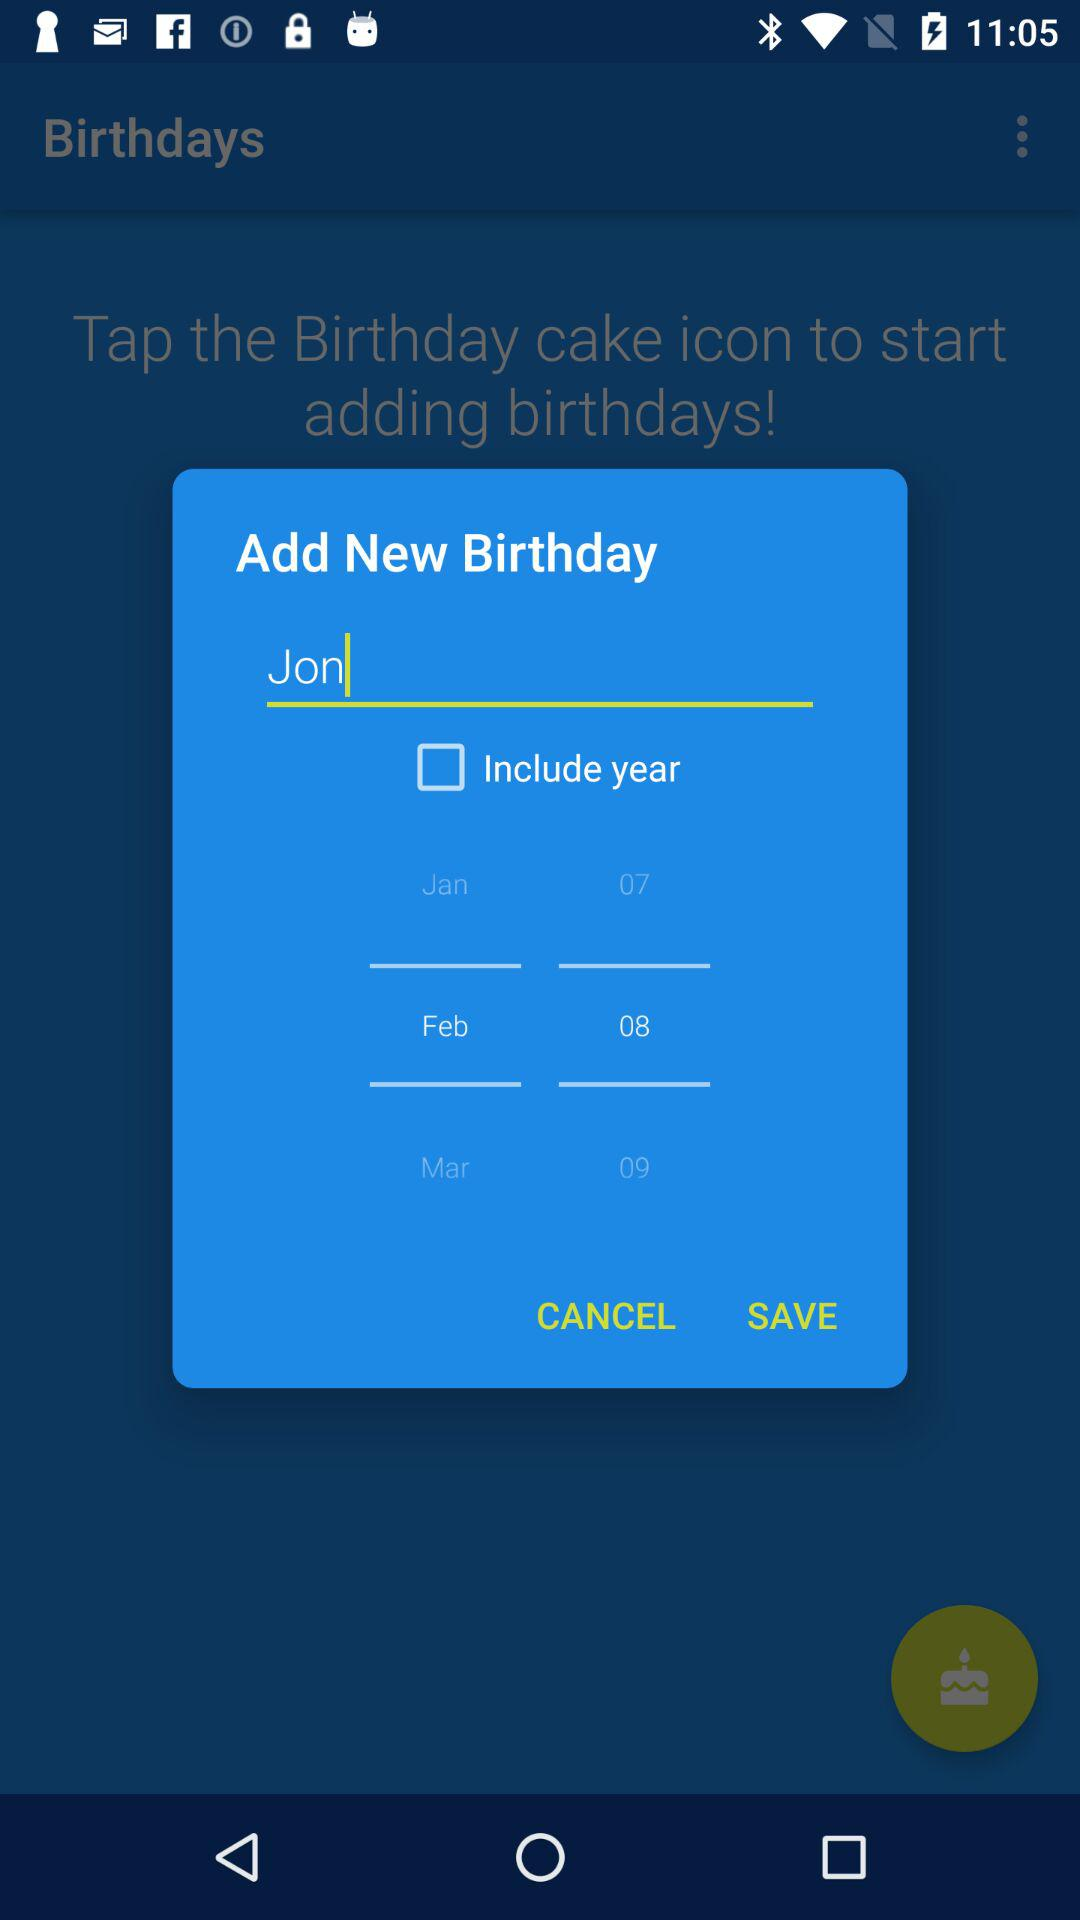What is the name? The name is "Jon". 